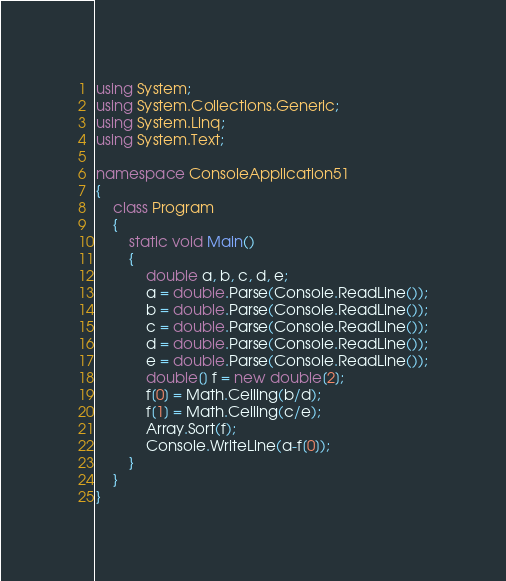Convert code to text. <code><loc_0><loc_0><loc_500><loc_500><_C#_>using System;
using System.Collections.Generic;
using System.Linq;
using System.Text;

namespace ConsoleApplication51
{
    class Program
    {
        static void Main()
        {
            double a, b, c, d, e;
            a = double.Parse(Console.ReadLine());
            b = double.Parse(Console.ReadLine());
            c = double.Parse(Console.ReadLine());
            d = double.Parse(Console.ReadLine());
            e = double.Parse(Console.ReadLine());
            double[] f = new double[2];
            f[0] = Math.Ceiling(b/d);
            f[1] = Math.Ceiling(c/e);
            Array.Sort(f);
            Console.WriteLine(a-f[0]);
        }
    }
}</code> 